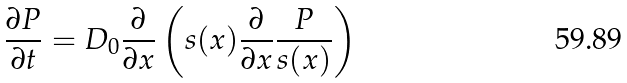Convert formula to latex. <formula><loc_0><loc_0><loc_500><loc_500>\frac { \partial P } { \partial t } = D _ { 0 } \frac { \partial } { \partial x } \left ( s ( x ) \frac { \partial } { \partial x } \frac { P } { s ( x ) } \right )</formula> 